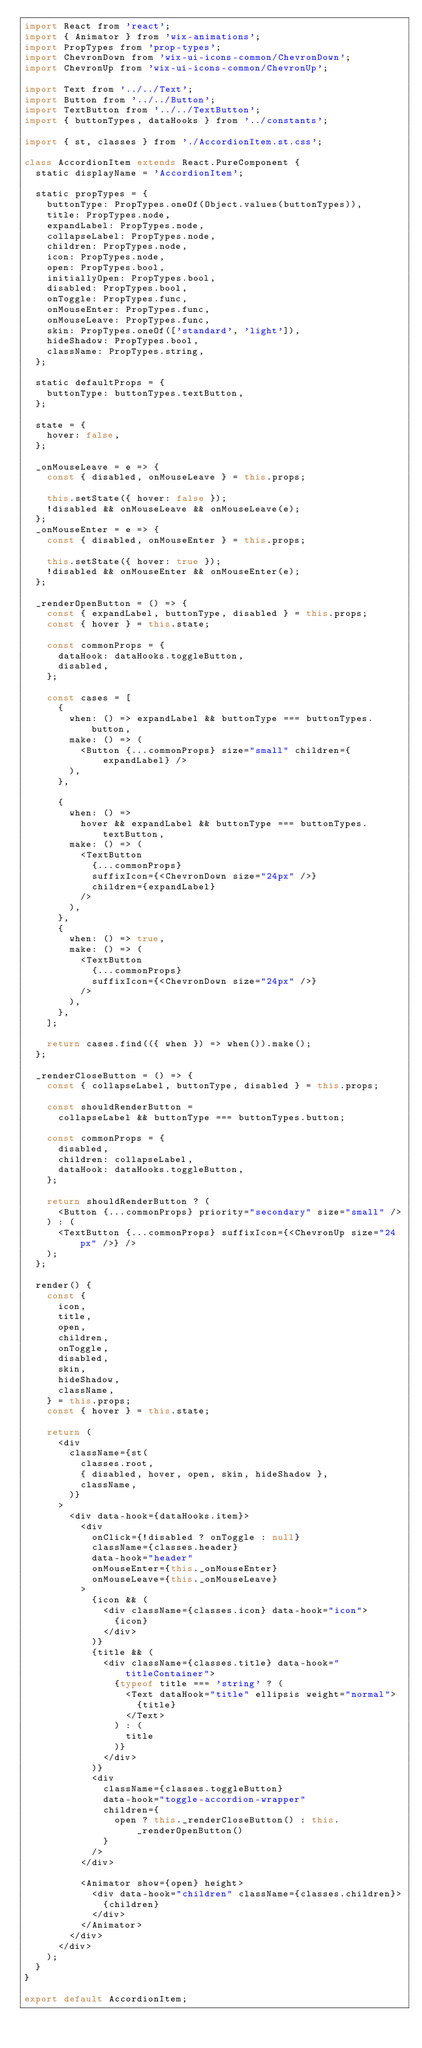<code> <loc_0><loc_0><loc_500><loc_500><_JavaScript_>import React from 'react';
import { Animator } from 'wix-animations';
import PropTypes from 'prop-types';
import ChevronDown from 'wix-ui-icons-common/ChevronDown';
import ChevronUp from 'wix-ui-icons-common/ChevronUp';

import Text from '../../Text';
import Button from '../../Button';
import TextButton from '../../TextButton';
import { buttonTypes, dataHooks } from '../constants';

import { st, classes } from './AccordionItem.st.css';

class AccordionItem extends React.PureComponent {
  static displayName = 'AccordionItem';

  static propTypes = {
    buttonType: PropTypes.oneOf(Object.values(buttonTypes)),
    title: PropTypes.node,
    expandLabel: PropTypes.node,
    collapseLabel: PropTypes.node,
    children: PropTypes.node,
    icon: PropTypes.node,
    open: PropTypes.bool,
    initiallyOpen: PropTypes.bool,
    disabled: PropTypes.bool,
    onToggle: PropTypes.func,
    onMouseEnter: PropTypes.func,
    onMouseLeave: PropTypes.func,
    skin: PropTypes.oneOf(['standard', 'light']),
    hideShadow: PropTypes.bool,
    className: PropTypes.string,
  };

  static defaultProps = {
    buttonType: buttonTypes.textButton,
  };

  state = {
    hover: false,
  };

  _onMouseLeave = e => {
    const { disabled, onMouseLeave } = this.props;

    this.setState({ hover: false });
    !disabled && onMouseLeave && onMouseLeave(e);
  };
  _onMouseEnter = e => {
    const { disabled, onMouseEnter } = this.props;

    this.setState({ hover: true });
    !disabled && onMouseEnter && onMouseEnter(e);
  };

  _renderOpenButton = () => {
    const { expandLabel, buttonType, disabled } = this.props;
    const { hover } = this.state;

    const commonProps = {
      dataHook: dataHooks.toggleButton,
      disabled,
    };

    const cases = [
      {
        when: () => expandLabel && buttonType === buttonTypes.button,
        make: () => (
          <Button {...commonProps} size="small" children={expandLabel} />
        ),
      },

      {
        when: () =>
          hover && expandLabel && buttonType === buttonTypes.textButton,
        make: () => (
          <TextButton
            {...commonProps}
            suffixIcon={<ChevronDown size="24px" />}
            children={expandLabel}
          />
        ),
      },
      {
        when: () => true,
        make: () => (
          <TextButton
            {...commonProps}
            suffixIcon={<ChevronDown size="24px" />}
          />
        ),
      },
    ];

    return cases.find(({ when }) => when()).make();
  };

  _renderCloseButton = () => {
    const { collapseLabel, buttonType, disabled } = this.props;

    const shouldRenderButton =
      collapseLabel && buttonType === buttonTypes.button;

    const commonProps = {
      disabled,
      children: collapseLabel,
      dataHook: dataHooks.toggleButton,
    };

    return shouldRenderButton ? (
      <Button {...commonProps} priority="secondary" size="small" />
    ) : (
      <TextButton {...commonProps} suffixIcon={<ChevronUp size="24px" />} />
    );
  };

  render() {
    const {
      icon,
      title,
      open,
      children,
      onToggle,
      disabled,
      skin,
      hideShadow,
      className,
    } = this.props;
    const { hover } = this.state;

    return (
      <div
        className={st(
          classes.root,
          { disabled, hover, open, skin, hideShadow },
          className,
        )}
      >
        <div data-hook={dataHooks.item}>
          <div
            onClick={!disabled ? onToggle : null}
            className={classes.header}
            data-hook="header"
            onMouseEnter={this._onMouseEnter}
            onMouseLeave={this._onMouseLeave}
          >
            {icon && (
              <div className={classes.icon} data-hook="icon">
                {icon}
              </div>
            )}
            {title && (
              <div className={classes.title} data-hook="titleContainer">
                {typeof title === 'string' ? (
                  <Text dataHook="title" ellipsis weight="normal">
                    {title}
                  </Text>
                ) : (
                  title
                )}
              </div>
            )}
            <div
              className={classes.toggleButton}
              data-hook="toggle-accordion-wrapper"
              children={
                open ? this._renderCloseButton() : this._renderOpenButton()
              }
            />
          </div>

          <Animator show={open} height>
            <div data-hook="children" className={classes.children}>
              {children}
            </div>
          </Animator>
        </div>
      </div>
    );
  }
}

export default AccordionItem;
</code> 